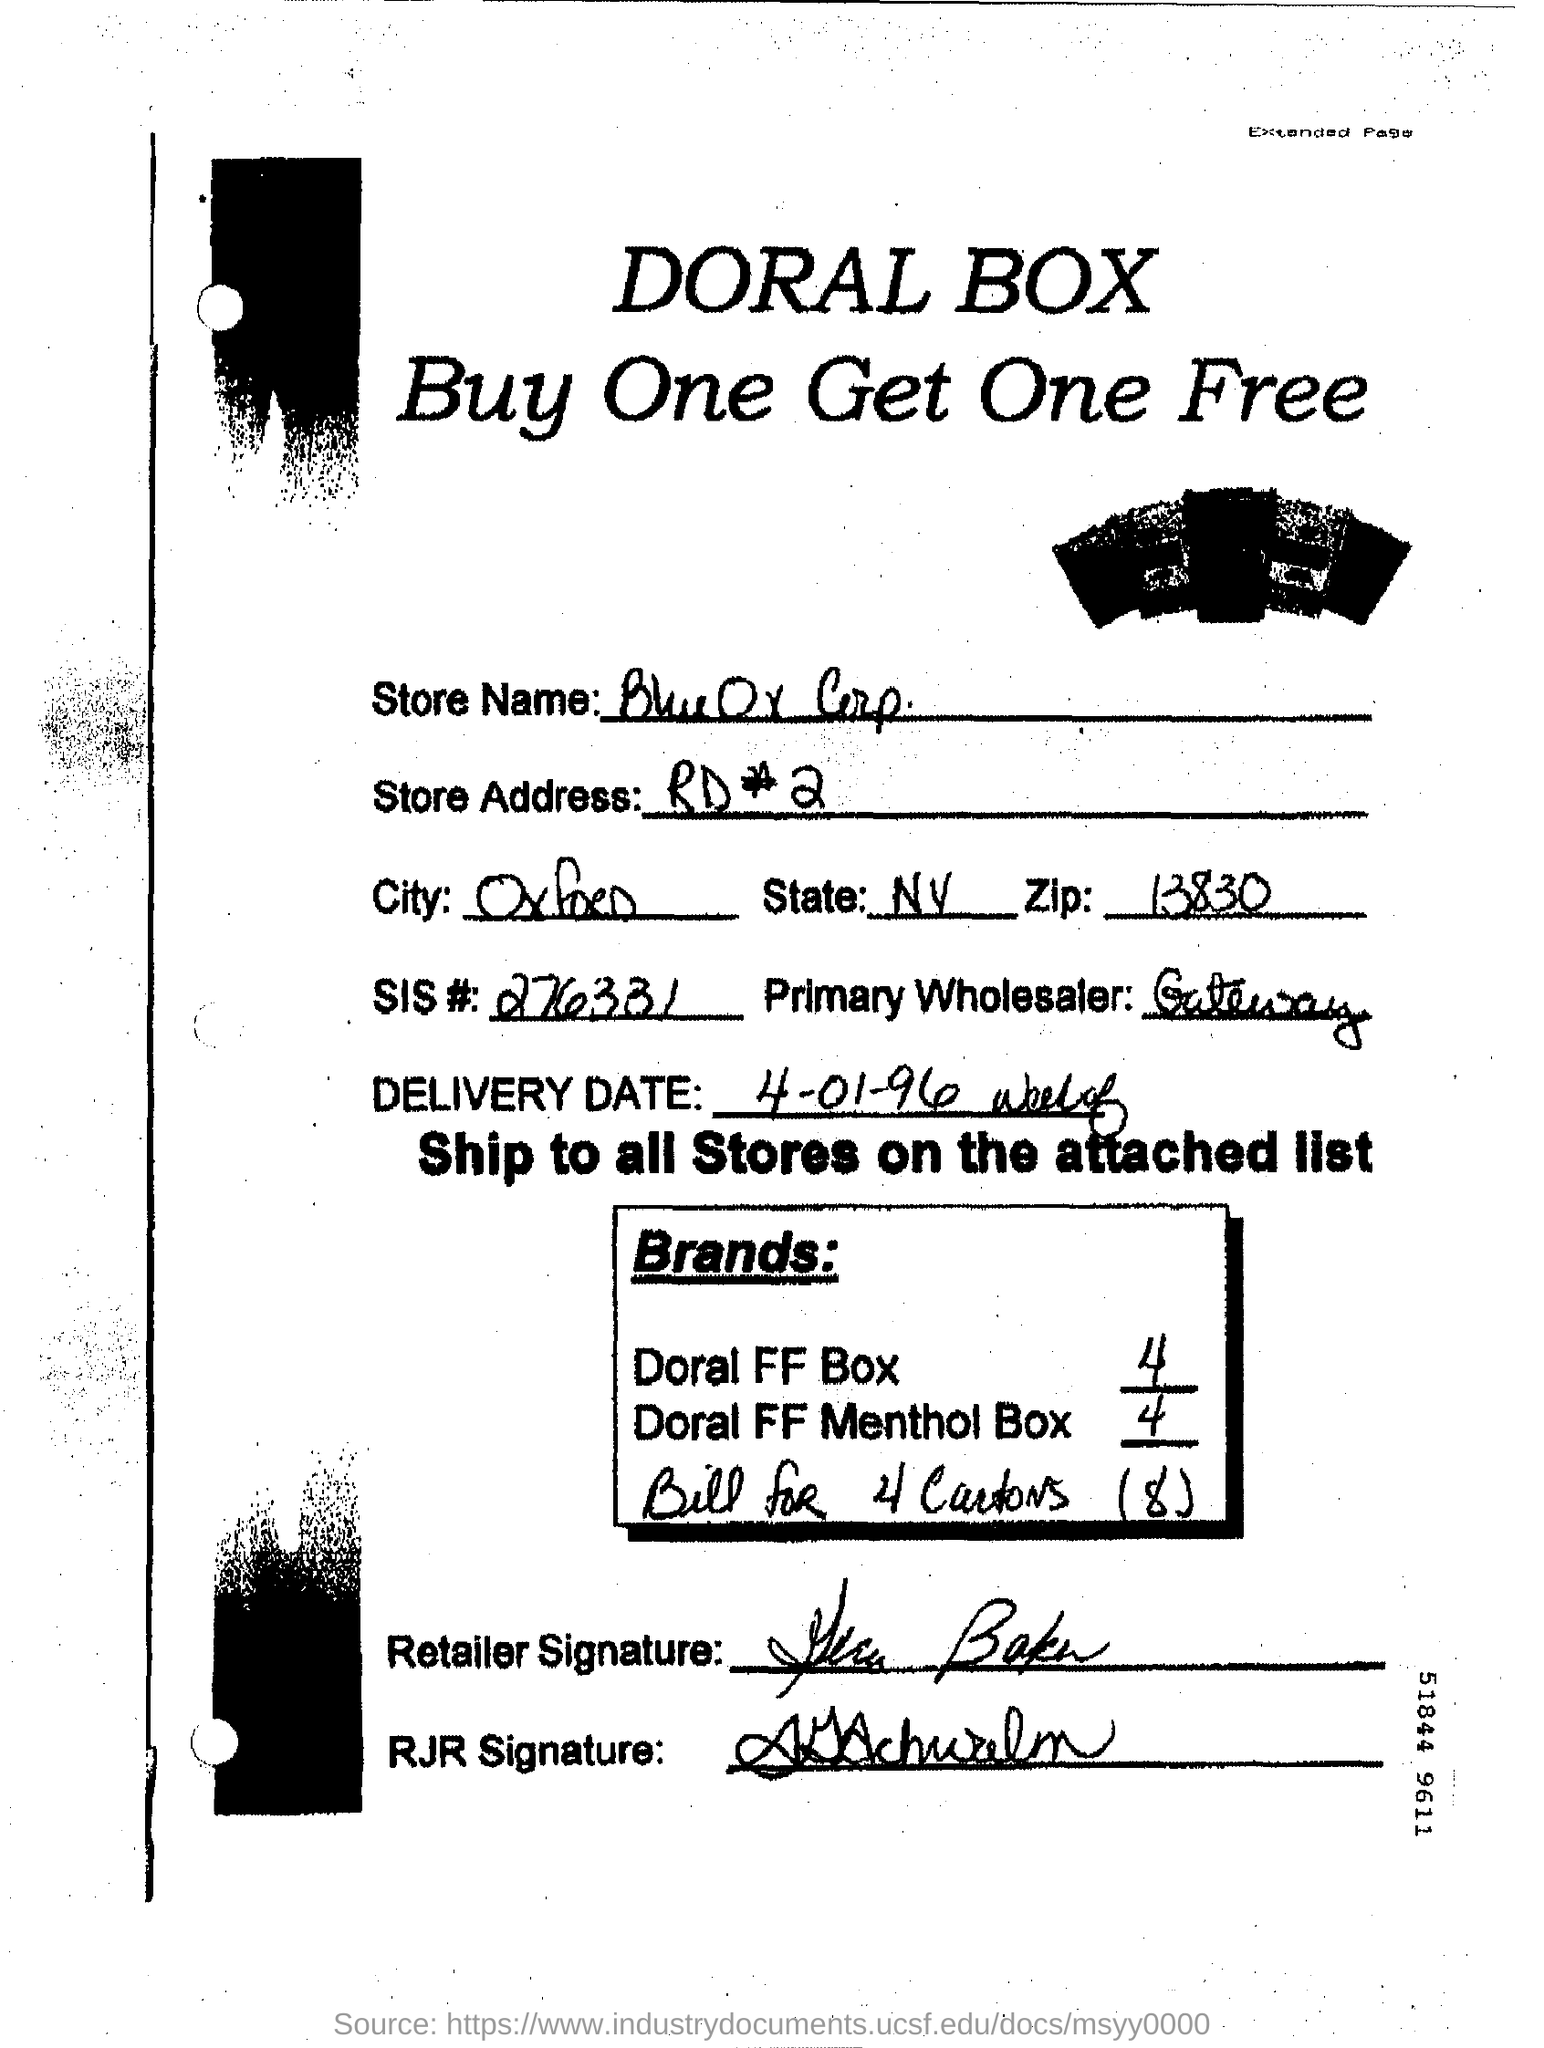Who is the Primary Wholesaler?
Offer a very short reply. Gateway. 